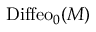<formula> <loc_0><loc_0><loc_500><loc_500>D i f f e o _ { 0 } ( M )</formula> 